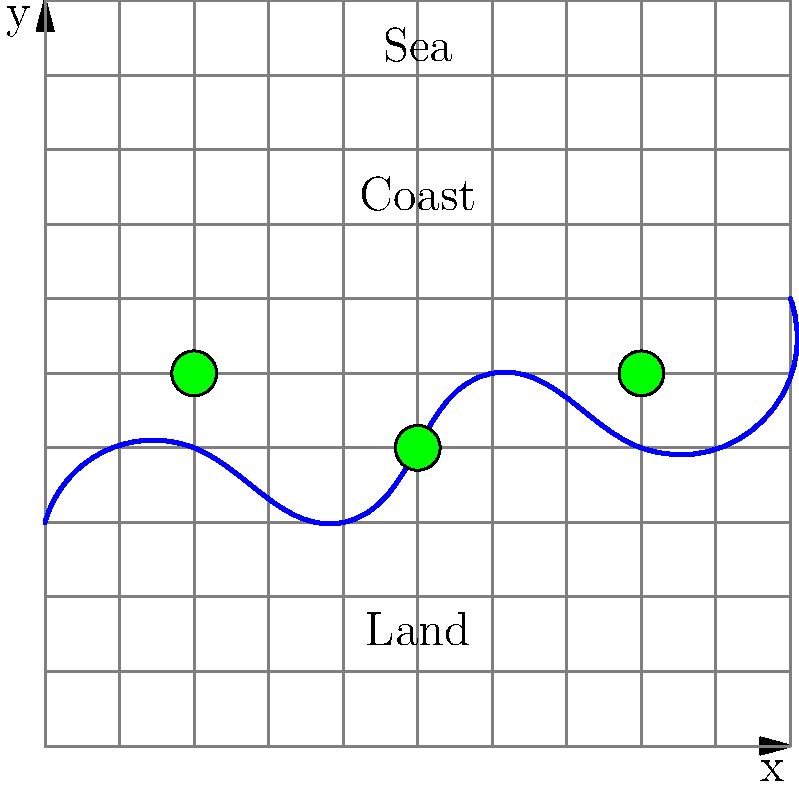In the coastal grid system shown, three coastal protection structures are placed at coordinates (2,5), (5,4), and (8,5). If the effectiveness of each structure decreases linearly with distance and covers a maximum range of 3 grid units, what is the total length of coastline effectively protected? To solve this problem, we need to follow these steps:

1. Identify the range of each protection structure:
   - Structure 1 at (2,5): covers x-coordinates from 0 to 5
   - Structure 2 at (5,4): covers x-coordinates from 2 to 8
   - Structure 3 at (8,5): covers x-coordinates from 5 to 10

2. Determine the overlapping coverage:
   - Structures 1 and 2 overlap from x = 2 to 5
   - Structures 2 and 3 overlap from x = 5 to 8

3. Calculate the total protected length:
   - Total range covered: x = 0 to 10
   - Length of coastline = 10 grid units

4. Check if any parts of the coastline are not covered:
   - The entire coastline is within the range of at least one structure

5. Conclude:
   Since the entire coastline from x = 0 to 10 is covered by at least one protection structure, the total length of coastline effectively protected is 10 grid units.
Answer: 10 grid units 